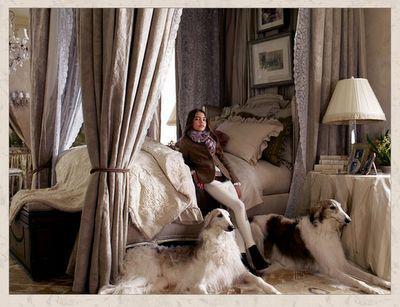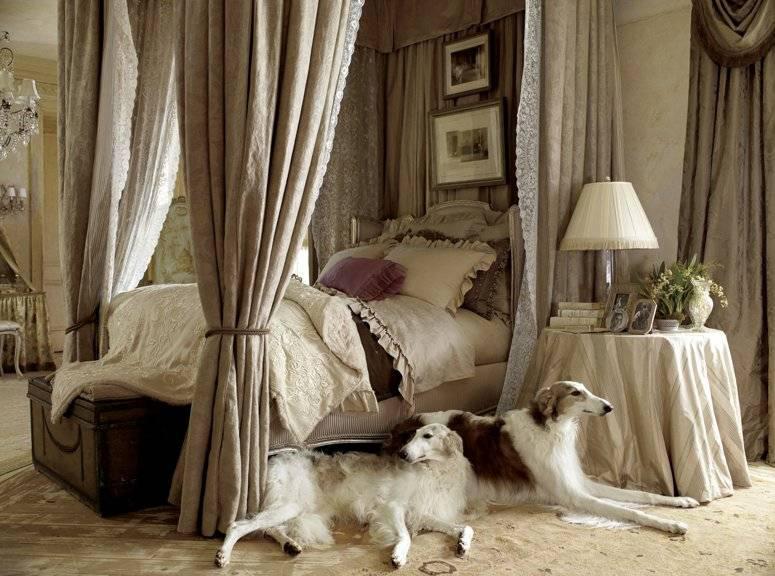The first image is the image on the left, the second image is the image on the right. Considering the images on both sides, is "A lady wearing a long dress is with her dogs in at least one of the images." valid? Answer yes or no. No. The first image is the image on the left, the second image is the image on the right. Considering the images on both sides, is "There are three dogs in the image pair." valid? Answer yes or no. No. 